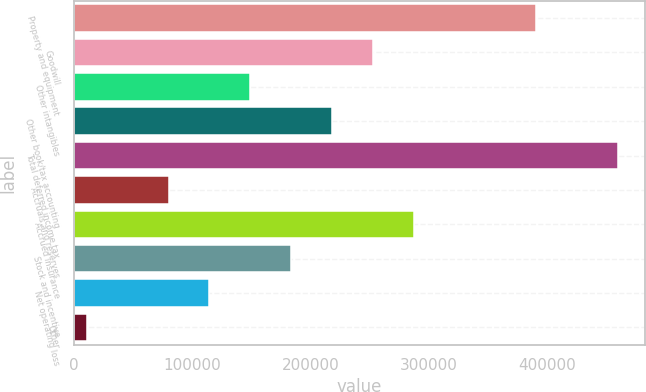Convert chart. <chart><loc_0><loc_0><loc_500><loc_500><bar_chart><fcel>Property and equipment<fcel>Goodwill<fcel>Other intangibles<fcel>Other book/tax accounting<fcel>Total deferred income tax<fcel>Accruals and reserves<fcel>Accrued insurance<fcel>Stock and incentive<fcel>Net operating loss<fcel>Other<nl><fcel>391074<fcel>252827<fcel>149141<fcel>218265<fcel>460197<fcel>80017.6<fcel>287388<fcel>183703<fcel>114579<fcel>10894<nl></chart> 